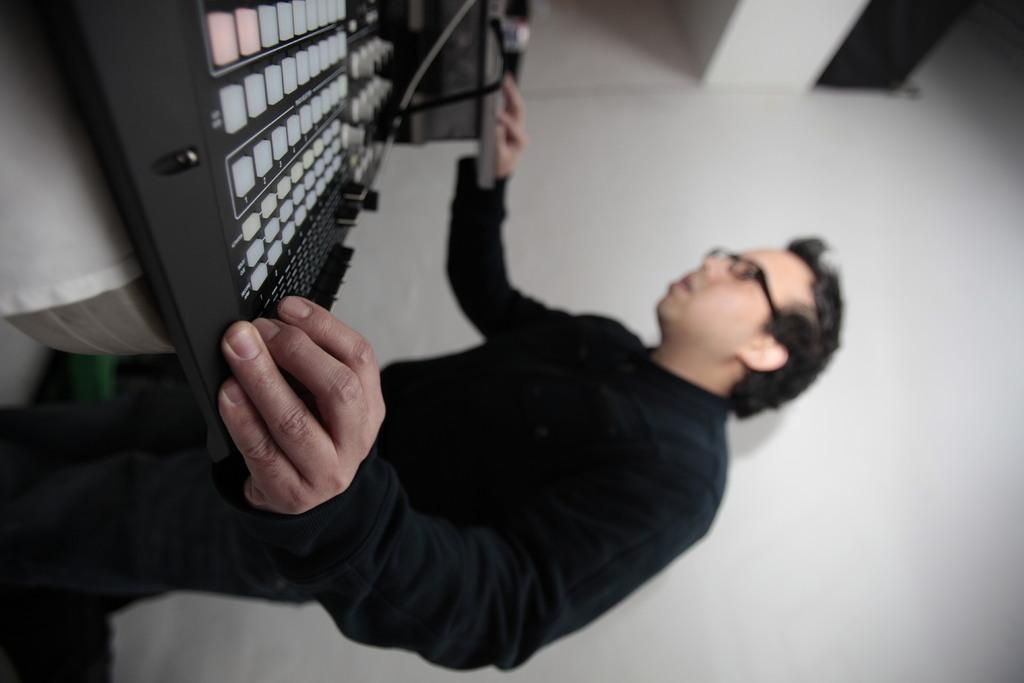What is the main subject in the image? There is a man standing in the image. What else can be seen in the image besides the man? There are music systems in the image. Where are the music systems located? The music systems are on an object. What is visible in the background of the image? There is a wall in the background of the image. What type of polish is the carpenter applying to the bricks in the image? There is no carpenter, polish, or bricks present in the image. 